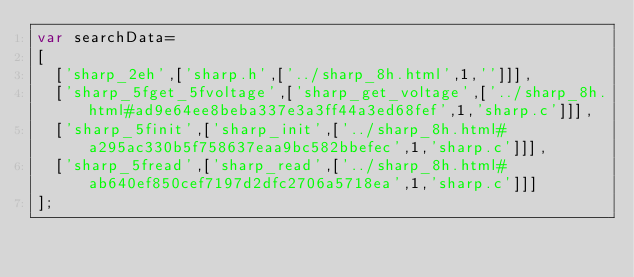<code> <loc_0><loc_0><loc_500><loc_500><_JavaScript_>var searchData=
[
  ['sharp_2eh',['sharp.h',['../sharp_8h.html',1,'']]],
  ['sharp_5fget_5fvoltage',['sharp_get_voltage',['../sharp_8h.html#ad9e64ee8beba337e3a3ff44a3ed68fef',1,'sharp.c']]],
  ['sharp_5finit',['sharp_init',['../sharp_8h.html#a295ac330b5f758637eaa9bc582bbefec',1,'sharp.c']]],
  ['sharp_5fread',['sharp_read',['../sharp_8h.html#ab640ef850cef7197d2dfc2706a5718ea',1,'sharp.c']]]
];
</code> 